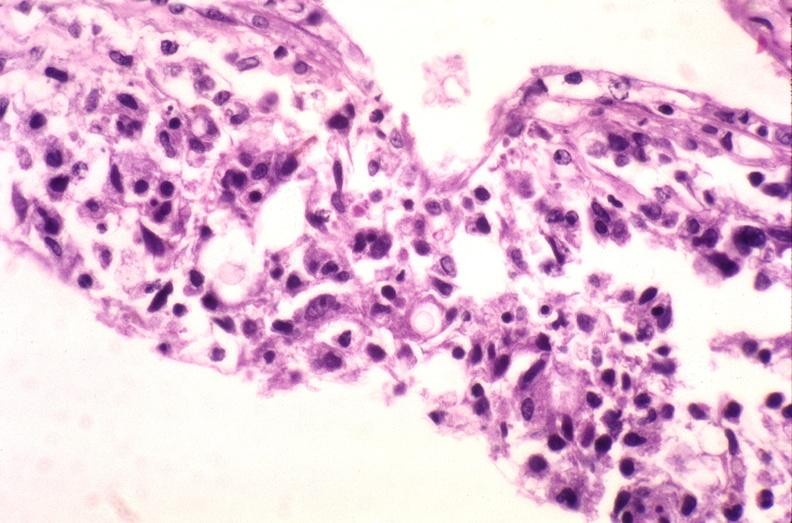where is this?
Answer the question using a single word or phrase. Nervous 